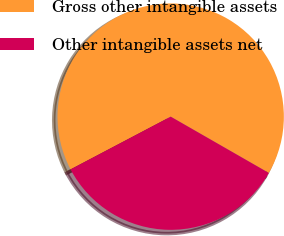<chart> <loc_0><loc_0><loc_500><loc_500><pie_chart><fcel>Gross other intangible assets<fcel>Other intangible assets net<nl><fcel>66.0%<fcel>34.0%<nl></chart> 